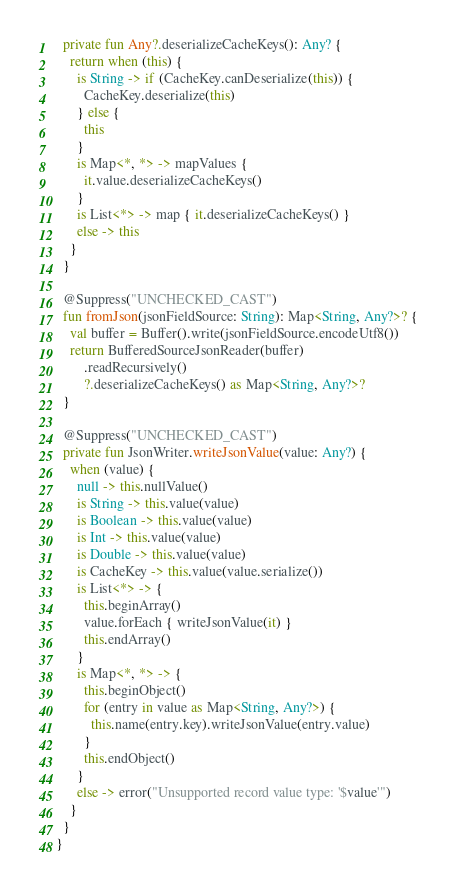Convert code to text. <code><loc_0><loc_0><loc_500><loc_500><_Kotlin_>  private fun Any?.deserializeCacheKeys(): Any? {
    return when (this) {
      is String -> if (CacheKey.canDeserialize(this)) {
        CacheKey.deserialize(this)
      } else {
        this
      }
      is Map<*, *> -> mapValues {
        it.value.deserializeCacheKeys()
      }
      is List<*> -> map { it.deserializeCacheKeys() }
      else -> this
    }
  }

  @Suppress("UNCHECKED_CAST")
  fun fromJson(jsonFieldSource: String): Map<String, Any?>? {
    val buffer = Buffer().write(jsonFieldSource.encodeUtf8())
    return BufferedSourceJsonReader(buffer)
        .readRecursively()
        ?.deserializeCacheKeys() as Map<String, Any?>?
  }

  @Suppress("UNCHECKED_CAST")
  private fun JsonWriter.writeJsonValue(value: Any?) {
    when (value) {
      null -> this.nullValue()
      is String -> this.value(value)
      is Boolean -> this.value(value)
      is Int -> this.value(value)
      is Double -> this.value(value)
      is CacheKey -> this.value(value.serialize())
      is List<*> -> {
        this.beginArray()
        value.forEach { writeJsonValue(it) }
        this.endArray()
      }
      is Map<*, *> -> {
        this.beginObject()
        for (entry in value as Map<String, Any?>) {
          this.name(entry.key).writeJsonValue(entry.value)
        }
        this.endObject()
      }
      else -> error("Unsupported record value type: '$value'")
    }
  }
}
</code> 